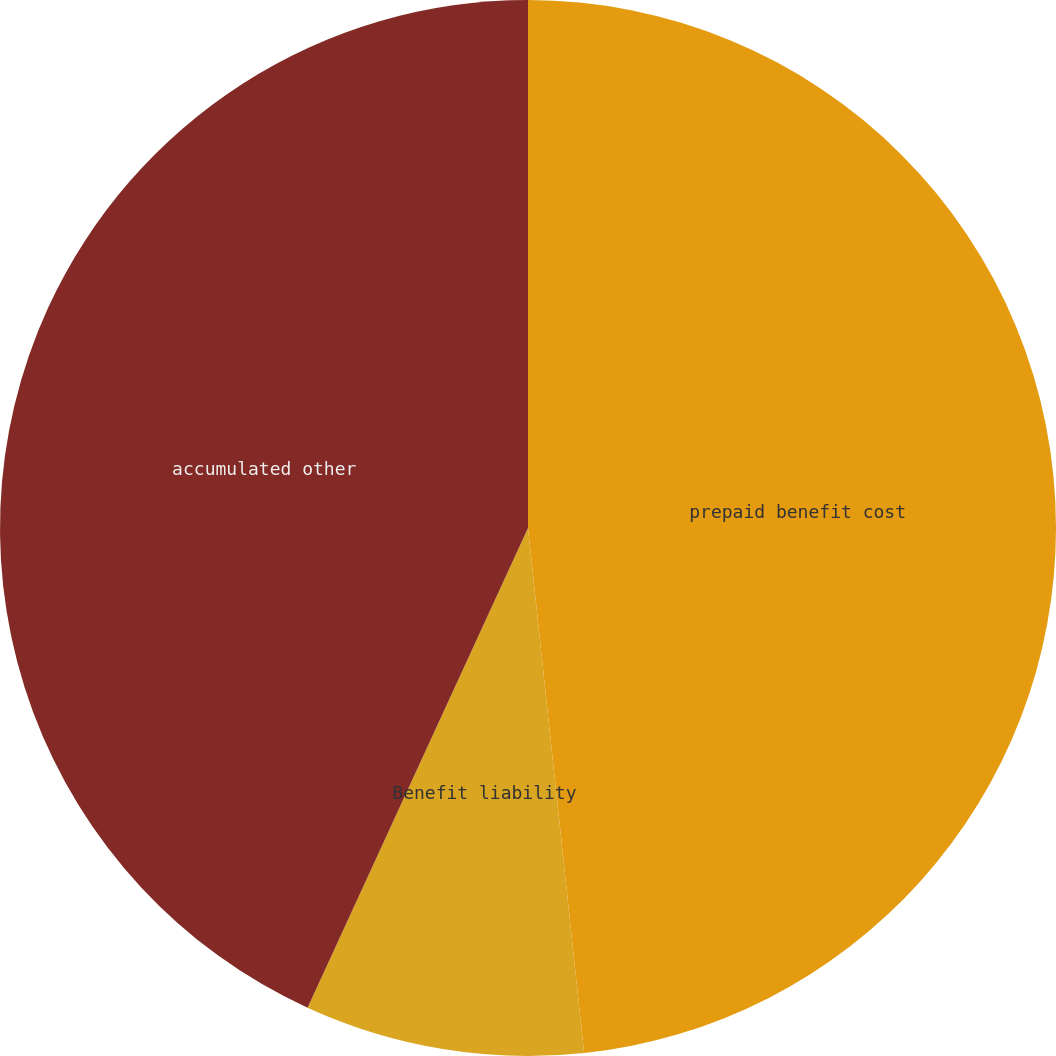<chart> <loc_0><loc_0><loc_500><loc_500><pie_chart><fcel>prepaid benefit cost<fcel>Benefit liability<fcel>accumulated other<nl><fcel>48.31%<fcel>8.55%<fcel>43.15%<nl></chart> 